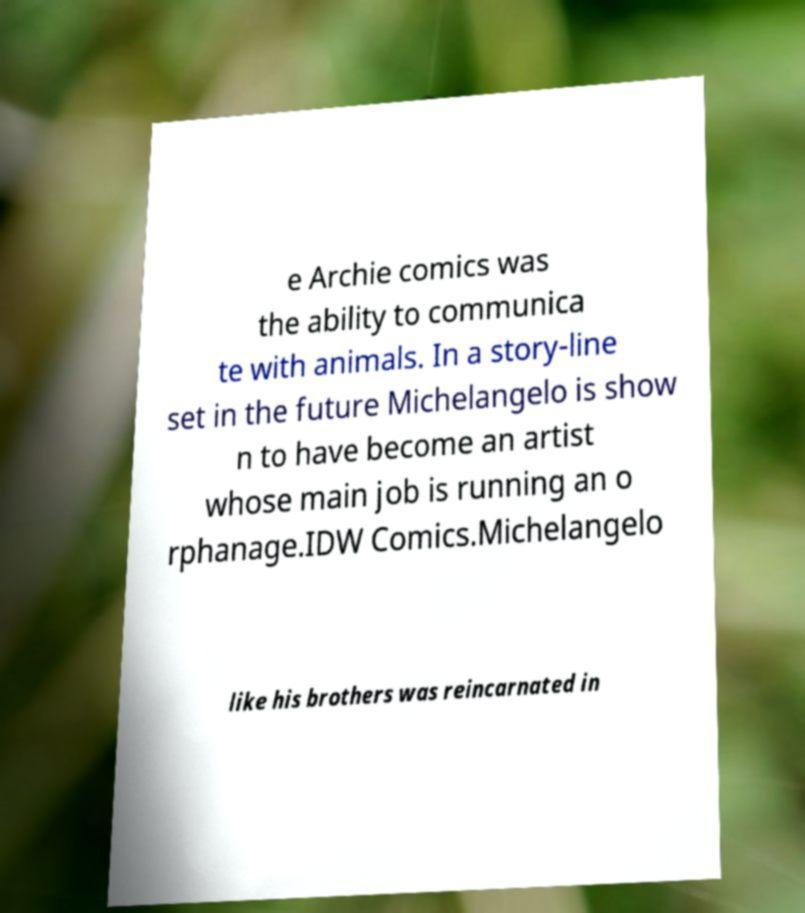Can you accurately transcribe the text from the provided image for me? e Archie comics was the ability to communica te with animals. In a story-line set in the future Michelangelo is show n to have become an artist whose main job is running an o rphanage.IDW Comics.Michelangelo like his brothers was reincarnated in 